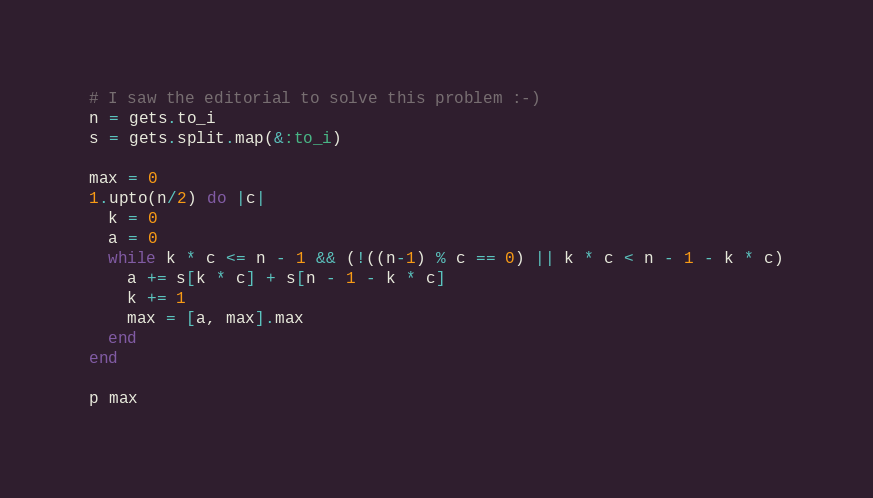Convert code to text. <code><loc_0><loc_0><loc_500><loc_500><_Ruby_># I saw the editorial to solve this problem :-)
n = gets.to_i
s = gets.split.map(&:to_i)

max = 0
1.upto(n/2) do |c|
  k = 0
  a = 0
  while k * c <= n - 1 && (!((n-1) % c == 0) || k * c < n - 1 - k * c)
    a += s[k * c] + s[n - 1 - k * c]
    k += 1
    max = [a, max].max
  end
end

p max
</code> 